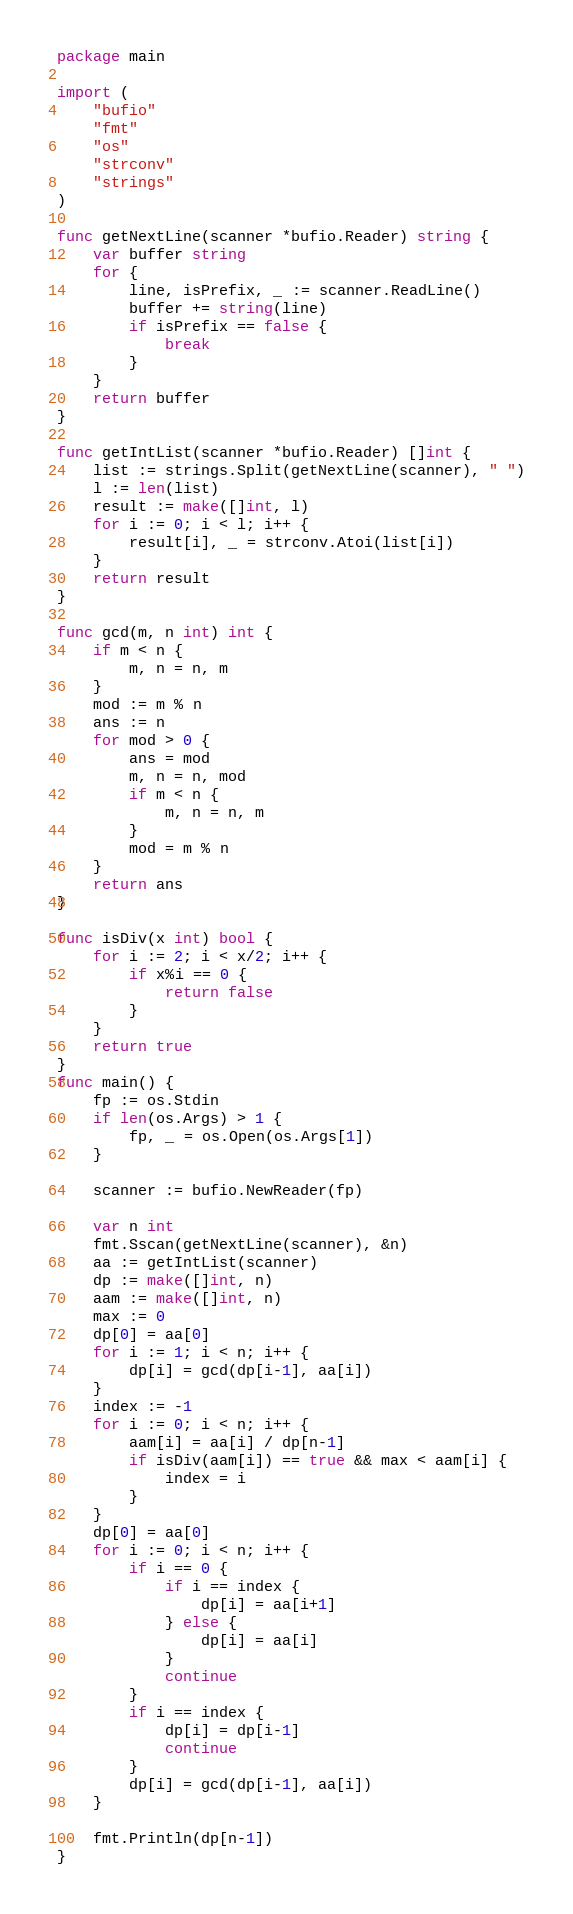<code> <loc_0><loc_0><loc_500><loc_500><_Go_>package main

import (
	"bufio"
	"fmt"
	"os"
	"strconv"
	"strings"
)

func getNextLine(scanner *bufio.Reader) string {
	var buffer string
	for {
		line, isPrefix, _ := scanner.ReadLine()
		buffer += string(line)
		if isPrefix == false {
			break
		}
	}
	return buffer
}

func getIntList(scanner *bufio.Reader) []int {
	list := strings.Split(getNextLine(scanner), " ")
	l := len(list)
	result := make([]int, l)
	for i := 0; i < l; i++ {
		result[i], _ = strconv.Atoi(list[i])
	}
	return result
}

func gcd(m, n int) int {
	if m < n {
		m, n = n, m
	}
	mod := m % n
	ans := n
	for mod > 0 {
		ans = mod
		m, n = n, mod
		if m < n {
			m, n = n, m
		}
		mod = m % n
	}
	return ans
}

func isDiv(x int) bool {
	for i := 2; i < x/2; i++ {
		if x%i == 0 {
			return false
		}
	}
	return true
}
func main() {
	fp := os.Stdin
	if len(os.Args) > 1 {
		fp, _ = os.Open(os.Args[1])
	}

	scanner := bufio.NewReader(fp)

	var n int
	fmt.Sscan(getNextLine(scanner), &n)
	aa := getIntList(scanner)
	dp := make([]int, n)
	aam := make([]int, n)
	max := 0
	dp[0] = aa[0]
	for i := 1; i < n; i++ {
		dp[i] = gcd(dp[i-1], aa[i])
	}
	index := -1
	for i := 0; i < n; i++ {
		aam[i] = aa[i] / dp[n-1]
		if isDiv(aam[i]) == true && max < aam[i] {
			index = i
		}
	}
	dp[0] = aa[0]
	for i := 0; i < n; i++ {
		if i == 0 {
			if i == index {
				dp[i] = aa[i+1]
			} else {
				dp[i] = aa[i]
			}
			continue
		}
		if i == index {
			dp[i] = dp[i-1]
			continue
		}
		dp[i] = gcd(dp[i-1], aa[i])
	}

	fmt.Println(dp[n-1])
}
</code> 